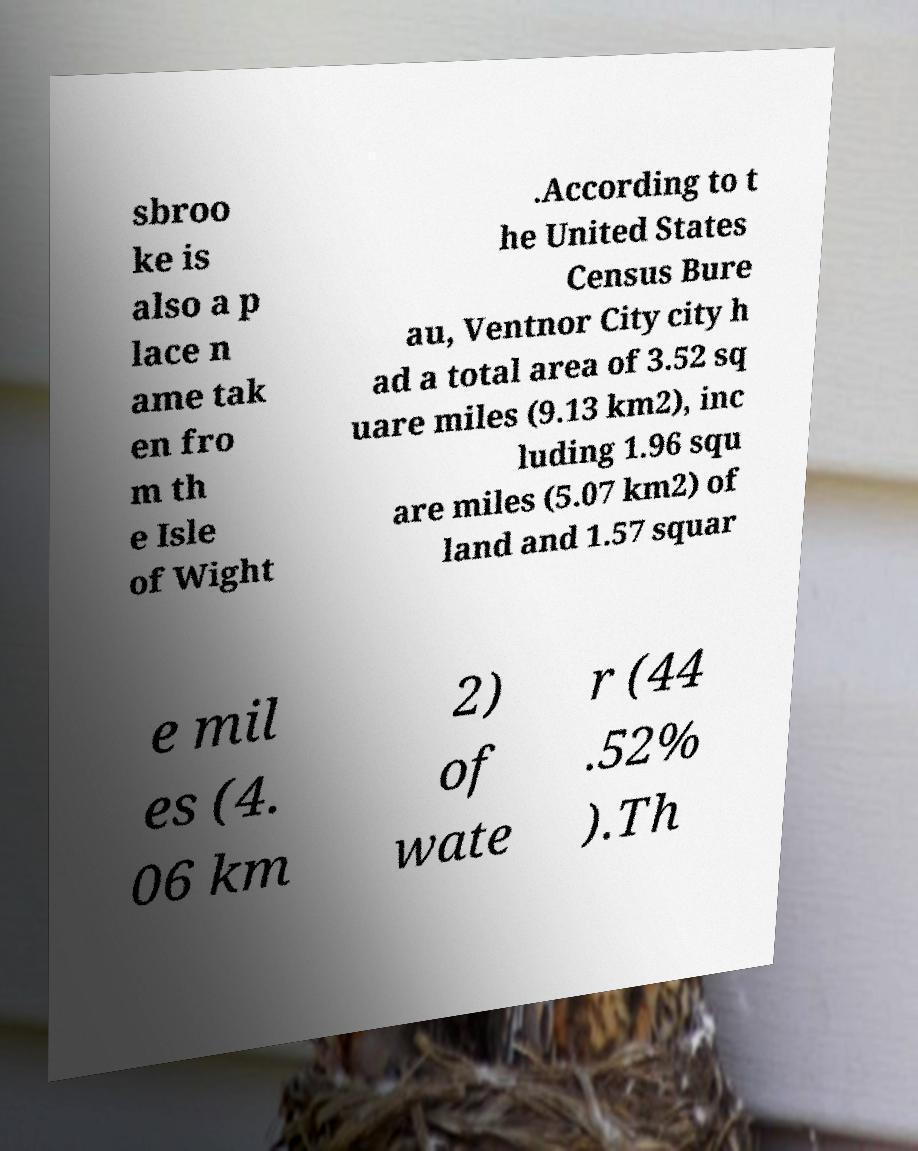For documentation purposes, I need the text within this image transcribed. Could you provide that? sbroo ke is also a p lace n ame tak en fro m th e Isle of Wight .According to t he United States Census Bure au, Ventnor City city h ad a total area of 3.52 sq uare miles (9.13 km2), inc luding 1.96 squ are miles (5.07 km2) of land and 1.57 squar e mil es (4. 06 km 2) of wate r (44 .52% ).Th 